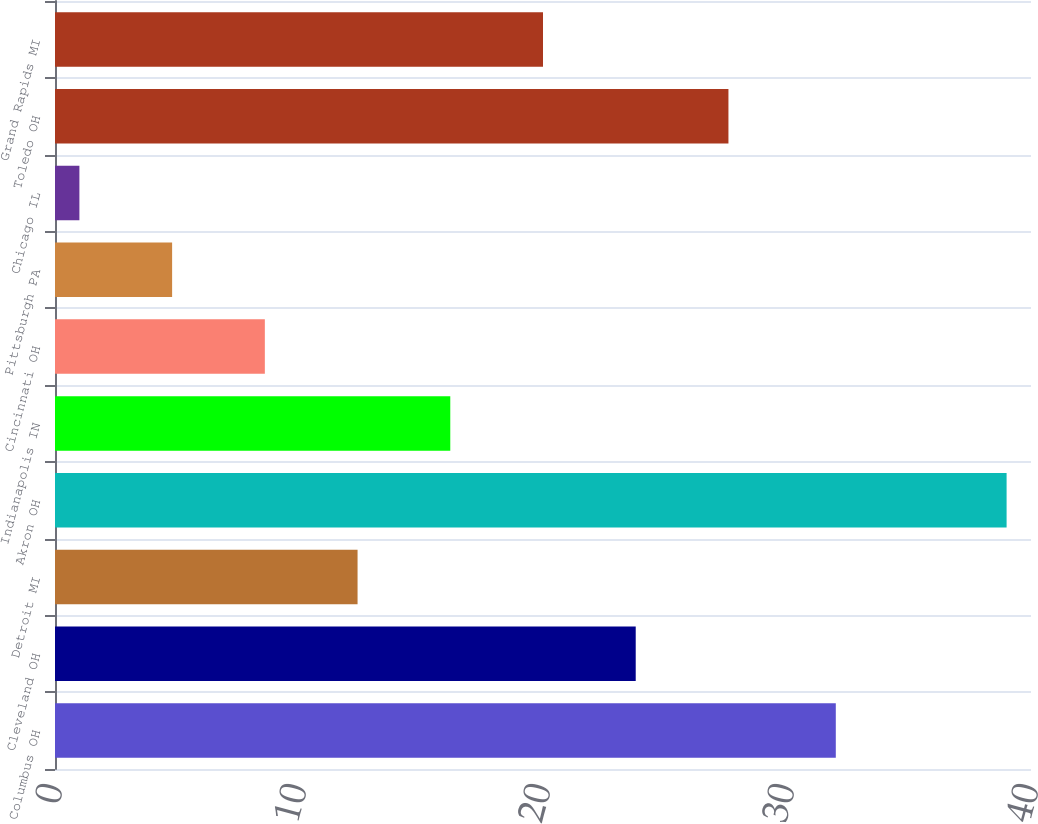Convert chart. <chart><loc_0><loc_0><loc_500><loc_500><bar_chart><fcel>Columbus OH<fcel>Cleveland OH<fcel>Detroit MI<fcel>Akron OH<fcel>Indianapolis IN<fcel>Cincinnati OH<fcel>Pittsburgh PA<fcel>Chicago IL<fcel>Toledo OH<fcel>Grand Rapids MI<nl><fcel>32<fcel>23.8<fcel>12.4<fcel>39<fcel>16.2<fcel>8.6<fcel>4.8<fcel>1<fcel>27.6<fcel>20<nl></chart> 